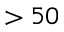<formula> <loc_0><loc_0><loc_500><loc_500>> 5 0</formula> 